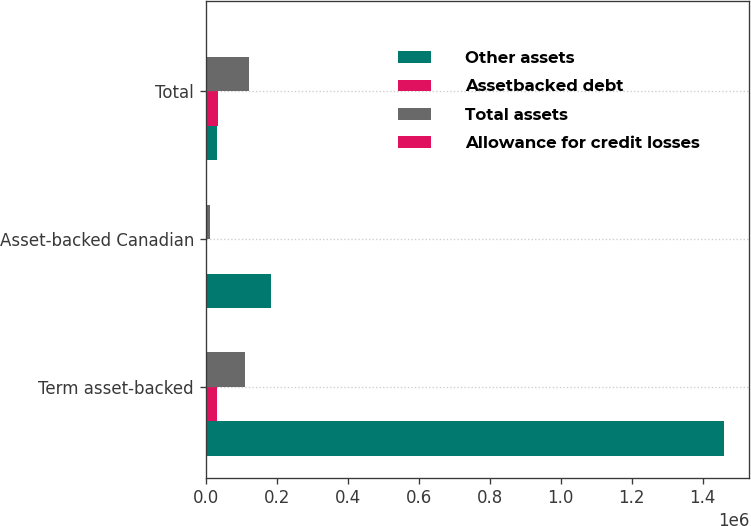<chart> <loc_0><loc_0><loc_500><loc_500><stacked_bar_chart><ecel><fcel>Term asset-backed<fcel>Asset-backed Canadian<fcel>Total<nl><fcel>Other assets<fcel>1.4586e+06<fcel>185099<fcel>32156<nl><fcel>Assetbacked debt<fcel>32156<fcel>2965<fcel>35121<nl><fcel>Total assets<fcel>110017<fcel>12035<fcel>122052<nl><fcel>Allowance for credit losses<fcel>2987<fcel>262<fcel>3671<nl></chart> 